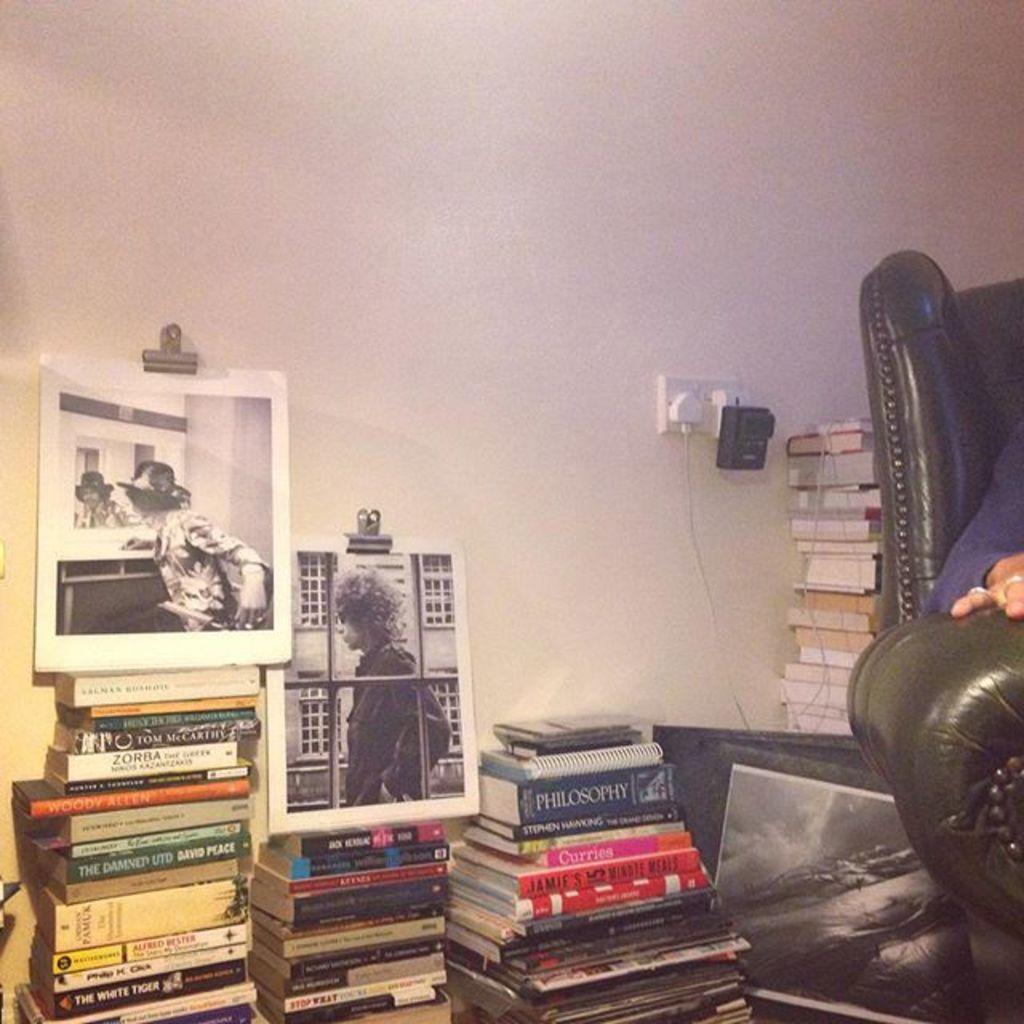In one or two sentences, can you explain what this image depicts? In this image we can see books, wall, depictions of persons. To the right side of the image there is a chair. 